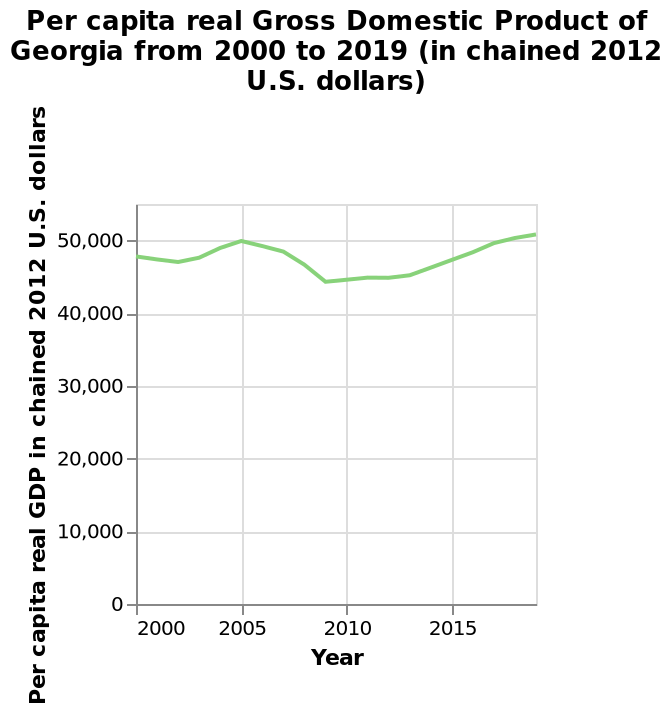<image>
What unit is used to measure the Per capita real GDP in the area chart? The Per capita real GDP is measured in chained 2012 U.S. dollars. How would you describe the overall change depicted in the chart? The chart depicts a combination of increases and decreases over the years. Offer a thorough analysis of the image. The chart shows over the years there has been an increase and decrease. What is the name of the line chart?  The line chart is named Per capita real Gross Domestic Product of Georgia from 2000 to 2019. 